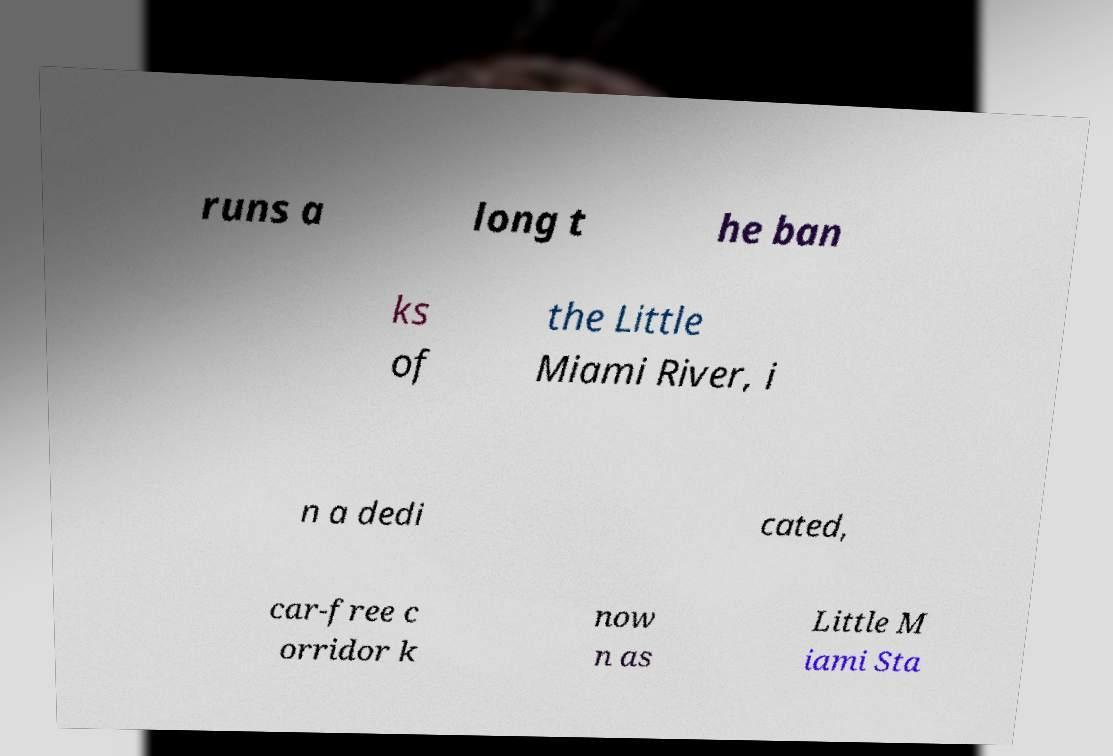Can you read and provide the text displayed in the image?This photo seems to have some interesting text. Can you extract and type it out for me? runs a long t he ban ks of the Little Miami River, i n a dedi cated, car-free c orridor k now n as Little M iami Sta 